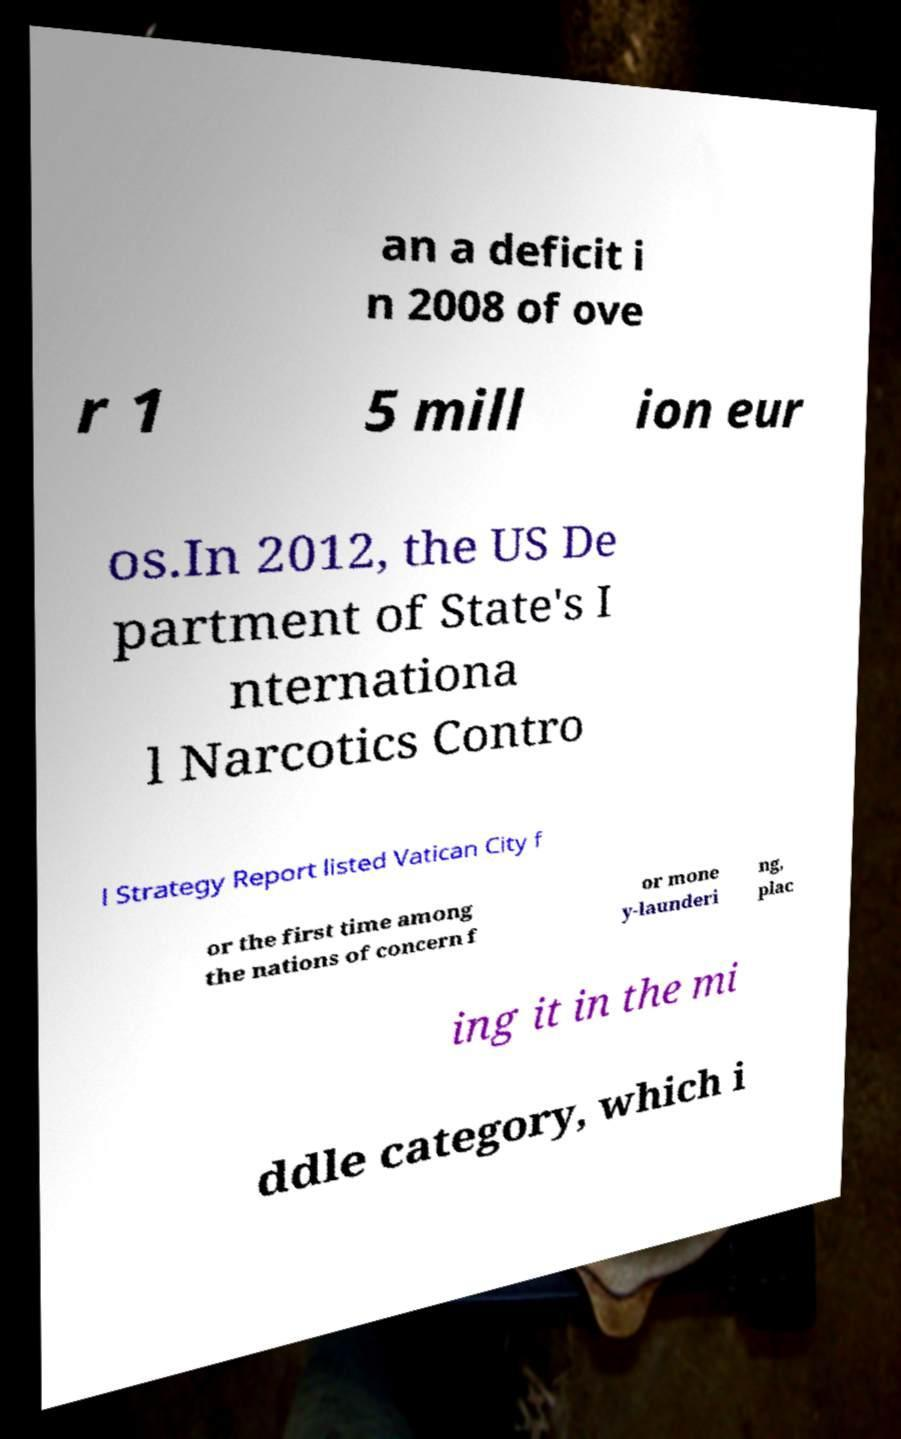Please read and relay the text visible in this image. What does it say? an a deficit i n 2008 of ove r 1 5 mill ion eur os.In 2012, the US De partment of State's I nternationa l Narcotics Contro l Strategy Report listed Vatican City f or the first time among the nations of concern f or mone y-launderi ng, plac ing it in the mi ddle category, which i 